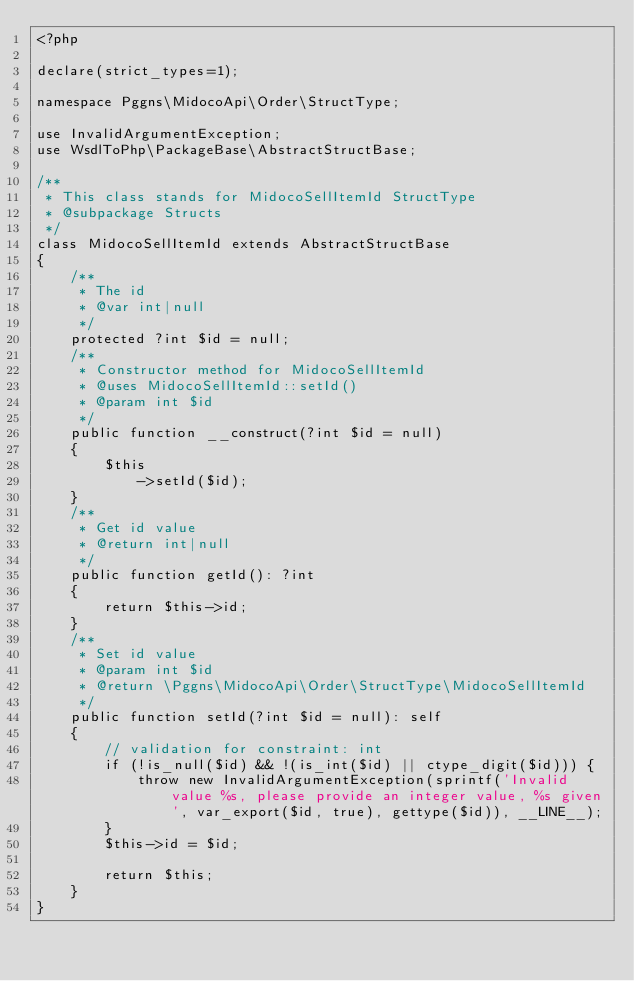<code> <loc_0><loc_0><loc_500><loc_500><_PHP_><?php

declare(strict_types=1);

namespace Pggns\MidocoApi\Order\StructType;

use InvalidArgumentException;
use WsdlToPhp\PackageBase\AbstractStructBase;

/**
 * This class stands for MidocoSellItemId StructType
 * @subpackage Structs
 */
class MidocoSellItemId extends AbstractStructBase
{
    /**
     * The id
     * @var int|null
     */
    protected ?int $id = null;
    /**
     * Constructor method for MidocoSellItemId
     * @uses MidocoSellItemId::setId()
     * @param int $id
     */
    public function __construct(?int $id = null)
    {
        $this
            ->setId($id);
    }
    /**
     * Get id value
     * @return int|null
     */
    public function getId(): ?int
    {
        return $this->id;
    }
    /**
     * Set id value
     * @param int $id
     * @return \Pggns\MidocoApi\Order\StructType\MidocoSellItemId
     */
    public function setId(?int $id = null): self
    {
        // validation for constraint: int
        if (!is_null($id) && !(is_int($id) || ctype_digit($id))) {
            throw new InvalidArgumentException(sprintf('Invalid value %s, please provide an integer value, %s given', var_export($id, true), gettype($id)), __LINE__);
        }
        $this->id = $id;
        
        return $this;
    }
}
</code> 